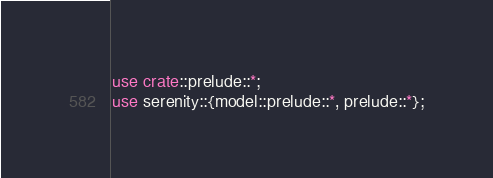<code> <loc_0><loc_0><loc_500><loc_500><_Rust_>use crate::prelude::*;
use serenity::{model::prelude::*, prelude::*};
</code> 